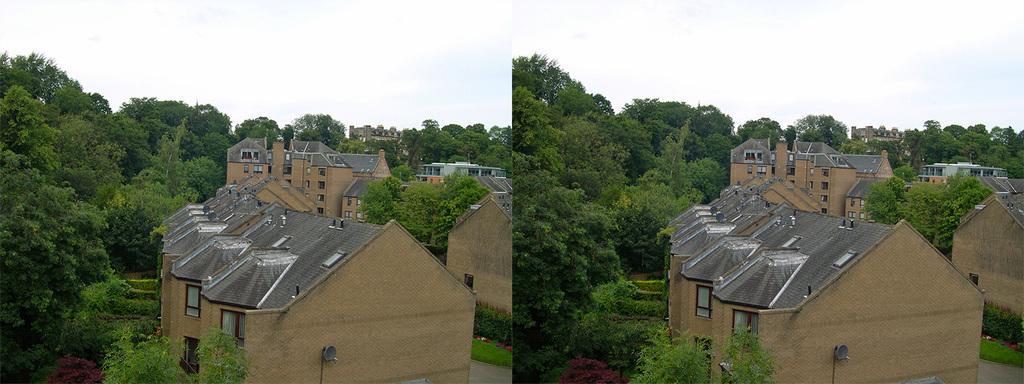In one or two sentences, can you explain what this image depicts? In this image I can see number of buildings, trees. In the background I can see clear view of sky. 